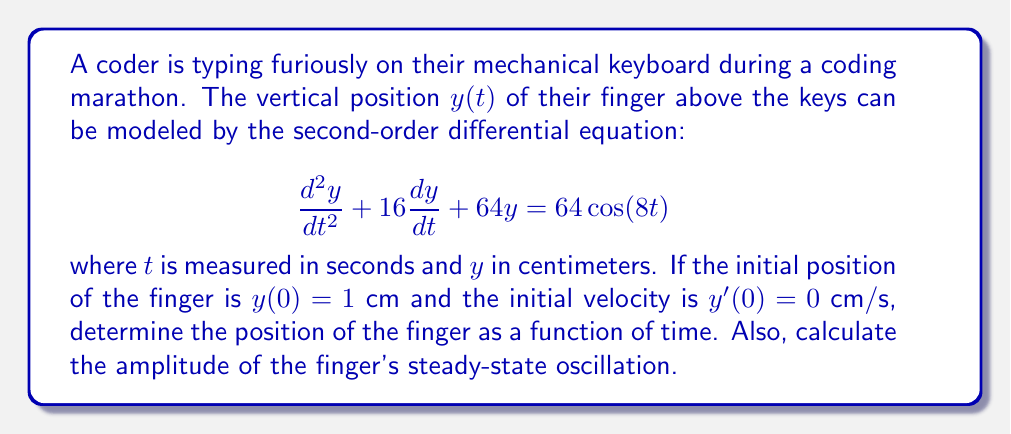Help me with this question. Let's approach this problem step by step:

1) The given differential equation is of the form:
   $$\frac{d^2y}{dt^2} + 2\zeta\omega_n\frac{dy}{dt} + \omega_n^2y = F\cos(\omega t)$$
   where $\zeta$ is the damping ratio, $\omega_n$ is the natural frequency, $F$ is the forcing amplitude, and $\omega$ is the forcing frequency.

2) From our equation, we can identify:
   $2\zeta\omega_n = 16$, $\omega_n^2 = 64$, $F = 64$, and $\omega = 8$

3) The general solution to this equation is of the form:
   $$y(t) = y_h(t) + y_p(t)$$
   where $y_h(t)$ is the homogeneous solution and $y_p(t)$ is the particular solution.

4) The homogeneous solution has the form:
   $$y_h(t) = e^{-\zeta\omega_n t}(A\cos(\omega_d t) + B\sin(\omega_d t))$$
   where $\omega_d = \omega_n\sqrt{1-\zeta^2}$

5) We can calculate:
   $\omega_n = \sqrt{64} = 8$
   $\zeta = \frac{16}{2\omega_n} = 1$

6) Since $\zeta = 1$, this is a critically damped system. The homogeneous solution becomes:
   $$y_h(t) = e^{-8t}(A + Bt)$$

7) The particular solution has the form:
   $$y_p(t) = M\cos(8t) + N\sin(8t)$$

8) Substituting this into the original equation and solving for $M$ and $N$:
   $$M = \frac{64(64-64)}{(64-64)^2 + (16\cdot8)^2} = 0$$
   $$N = \frac{-64(16\cdot8)}{(64-64)^2 + (16\cdot8)^2} = -0.5$$

9) Therefore, the complete solution is:
   $$y(t) = e^{-8t}(A + Bt) - 0.5\sin(8t)$$

10) Using the initial conditions:
    $y(0) = 1$ gives $A = 1.5$
    $y'(0) = 0$ gives $B = 12$

11) The final solution is:
    $$y(t) = e^{-8t}(1.5 + 12t) - 0.5\sin(8t)$$

12) The steady-state oscillation is given by the particular solution:
    $$y_p(t) = -0.5\sin(8t)$$
    The amplitude of this oscillation is 0.5 cm.
Answer: The position of the finger as a function of time is:
$$y(t) = e^{-8t}(1.5 + 12t) - 0.5\sin(8t)$$
The amplitude of the steady-state oscillation is 0.5 cm. 